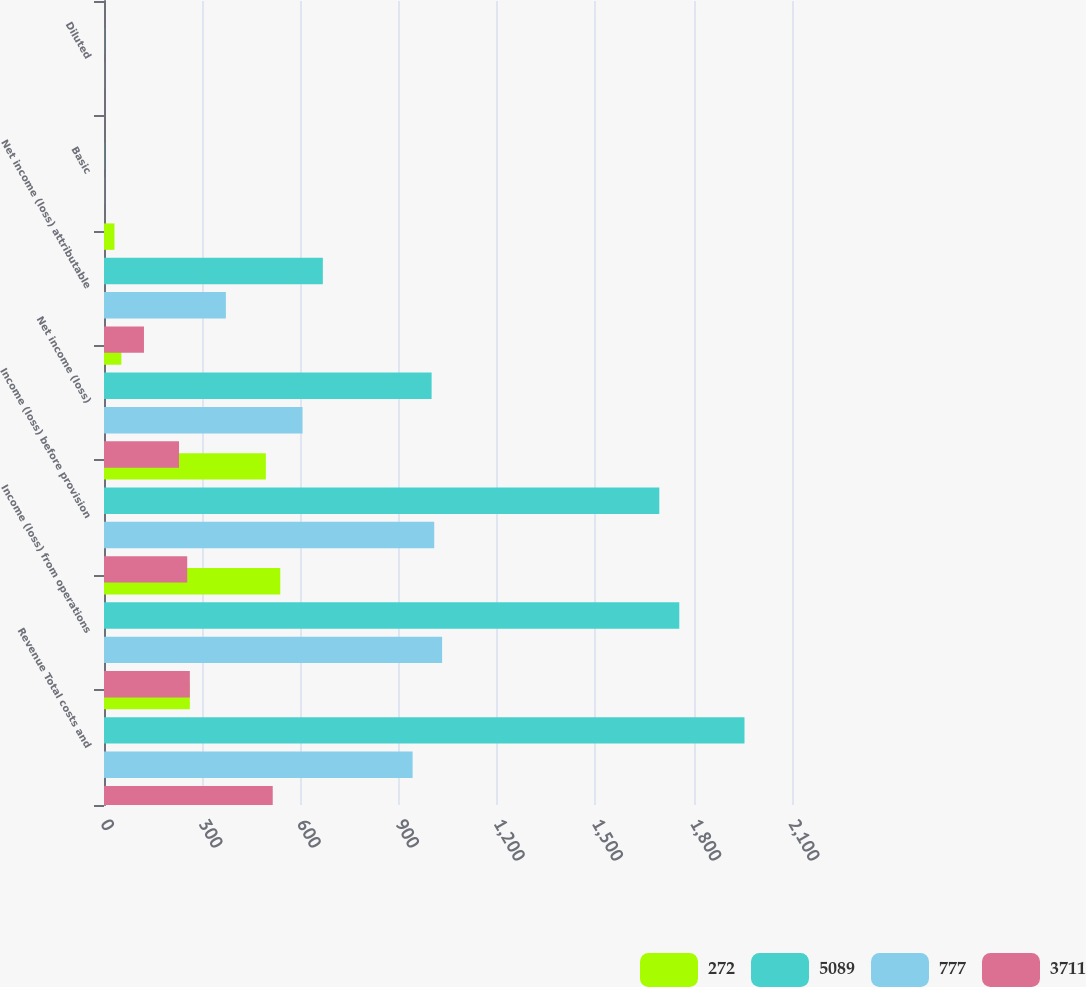Convert chart. <chart><loc_0><loc_0><loc_500><loc_500><stacked_bar_chart><ecel><fcel>Revenue Total costs and<fcel>Income (loss) from operations<fcel>Income (loss) before provision<fcel>Net income (loss)<fcel>Net income (loss) attributable<fcel>Basic<fcel>Diluted<nl><fcel>272<fcel>262<fcel>538<fcel>494<fcel>53<fcel>32<fcel>0.02<fcel>0.01<nl><fcel>5089<fcel>1955<fcel>1756<fcel>1695<fcel>1000<fcel>668<fcel>0.52<fcel>0.46<nl><fcel>777<fcel>942<fcel>1032<fcel>1008<fcel>606<fcel>372<fcel>0.34<fcel>0.28<nl><fcel>3711<fcel>515<fcel>262<fcel>254<fcel>229<fcel>122<fcel>0.12<fcel>0.1<nl></chart> 